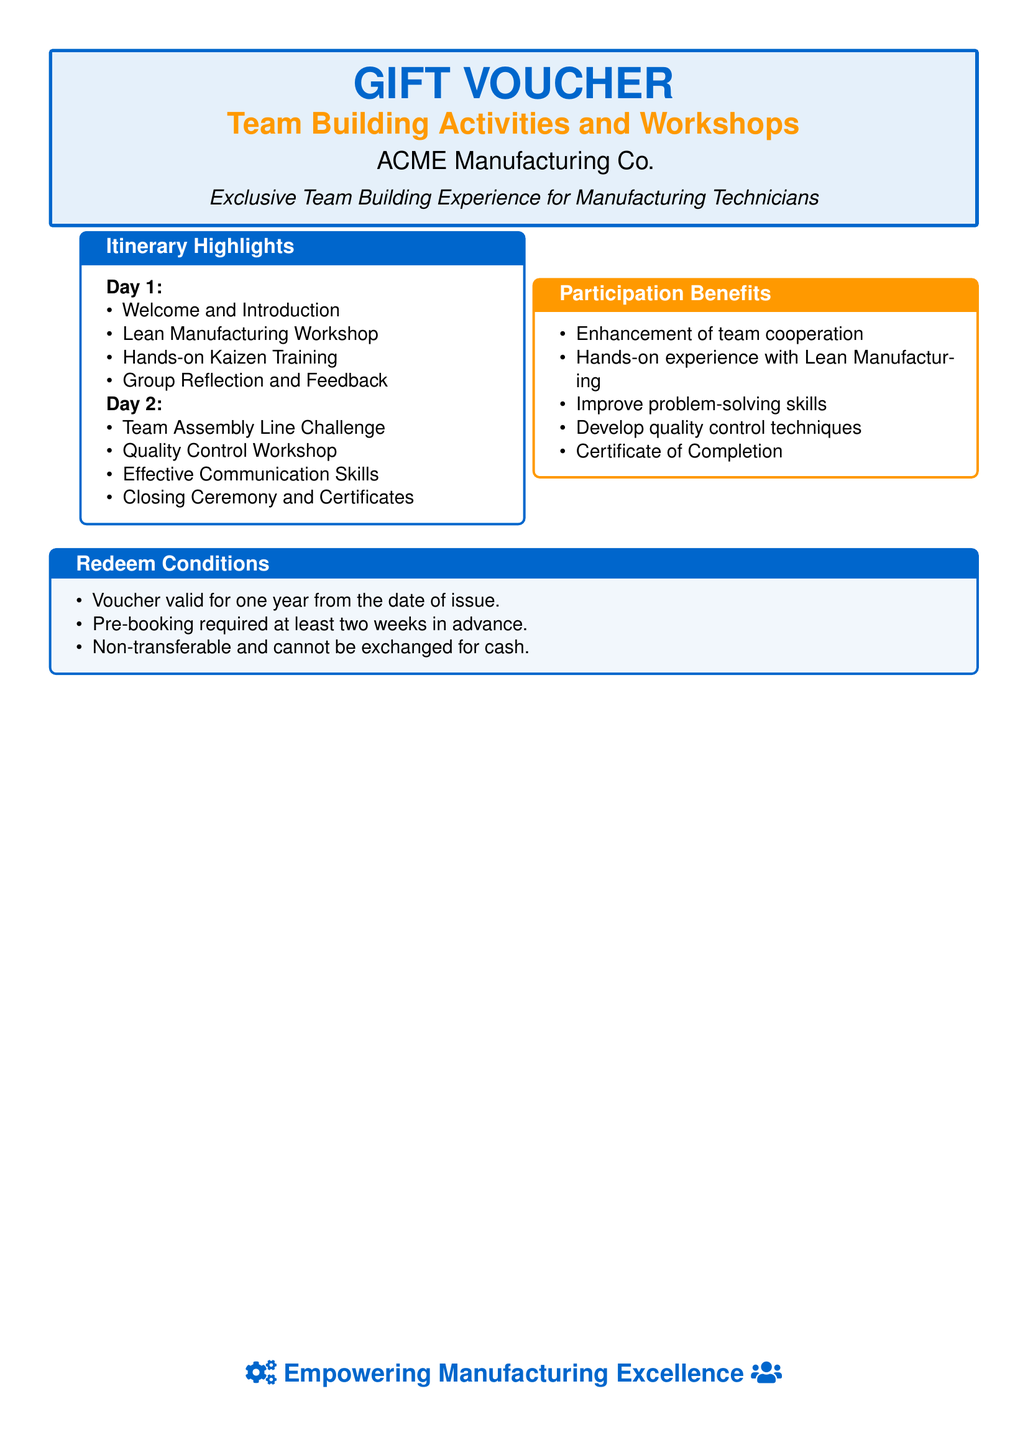What is the name of the company offering the voucher? The document states that the voucher is offered by ACME Manufacturing Co.
Answer: ACME Manufacturing Co How many days does the itinerary cover? The itinerary highlights provided specify activities for two days.
Answer: 2 days What workshop focuses on manufacturing improvement? The itinerary mentions a Lean Manufacturing Workshop as part of Day 1 activities.
Answer: Lean Manufacturing Workshop What skill is developed during the activities? The participation benefits outline "Improve problem-solving skills" as a key outcome.
Answer: Problem-solving skills Are there any conditions for redeeming the voucher? The document lists conditions under "Redeem Conditions," including validity and pre-booking requirements.
Answer: Yes How long is the voucher valid from the issue date? The redeem conditions specify the voucher is valid for one year from the date of issue.
Answer: One year What type of experience is the voucher aimed at providing? The document describes it as an "Exclusive Team Building Experience."
Answer: Team Building Experience What is provided upon completion of the activities? The participation benefits include a Certificate of Completion for participants.
Answer: Certificate of Completion What activity involves teamwork on Day 2? The itinerary highlights a "Team Assembly Line Challenge" as a day 2 activity.
Answer: Team Assembly Line Challenge 